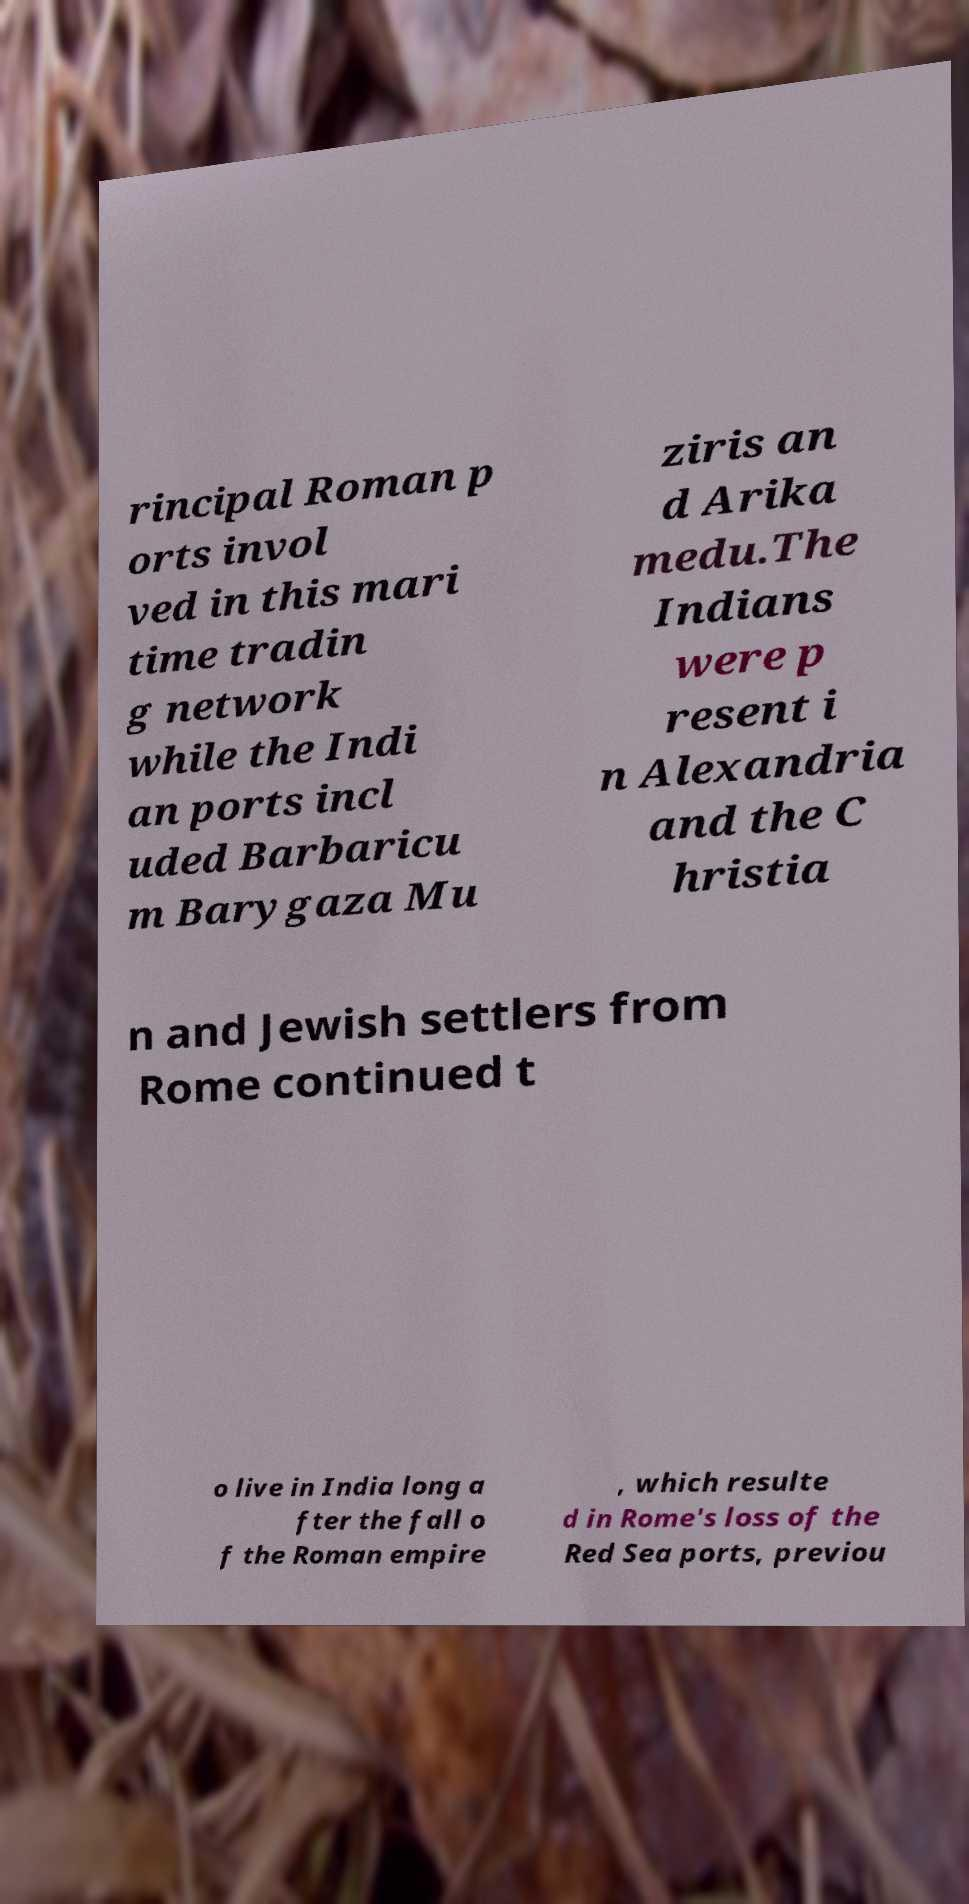Can you read and provide the text displayed in the image?This photo seems to have some interesting text. Can you extract and type it out for me? rincipal Roman p orts invol ved in this mari time tradin g network while the Indi an ports incl uded Barbaricu m Barygaza Mu ziris an d Arika medu.The Indians were p resent i n Alexandria and the C hristia n and Jewish settlers from Rome continued t o live in India long a fter the fall o f the Roman empire , which resulte d in Rome's loss of the Red Sea ports, previou 